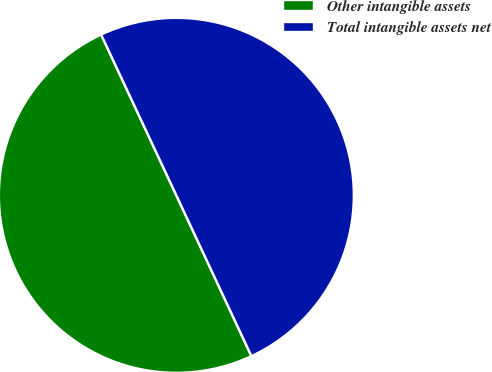Convert chart to OTSL. <chart><loc_0><loc_0><loc_500><loc_500><pie_chart><fcel>Other intangible assets<fcel>Total intangible assets net<nl><fcel>49.99%<fcel>50.01%<nl></chart> 